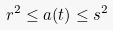<formula> <loc_0><loc_0><loc_500><loc_500>r ^ { 2 } \leq a ( t ) \leq s ^ { 2 }</formula> 